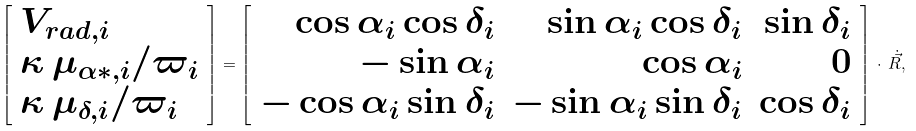Convert formula to latex. <formula><loc_0><loc_0><loc_500><loc_500>\left [ \begin{array} { l } V _ { r a d , i } \\ \kappa \, \mu _ { \alpha * , i } / \varpi _ { i } \\ \kappa \, \mu _ { \delta , i } / \varpi _ { i } \\ \end{array} \right ] = \left [ \begin{array} { r r r } \cos \alpha _ { i } \cos \delta _ { i } & \sin \alpha _ { i } \cos \delta _ { i } & \sin \delta _ { i } \\ - \sin \alpha _ { i } & \cos \alpha _ { i } & 0 \\ - \cos \alpha _ { i } \sin \delta _ { i } & - \sin \alpha _ { i } \sin \delta _ { i } & \cos \delta _ { i } \\ \end{array} \right ] \, \cdot \, \dot { \vec { R } } ,</formula> 